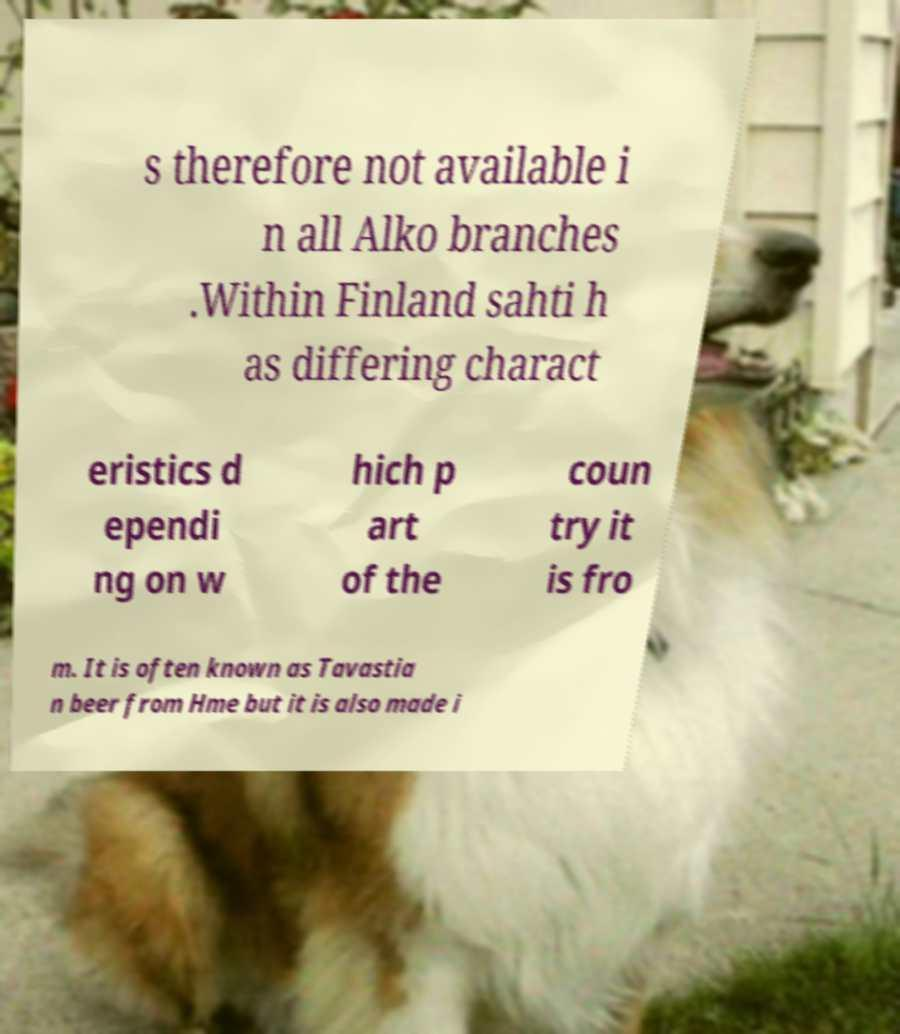Could you extract and type out the text from this image? s therefore not available i n all Alko branches .Within Finland sahti h as differing charact eristics d ependi ng on w hich p art of the coun try it is fro m. It is often known as Tavastia n beer from Hme but it is also made i 